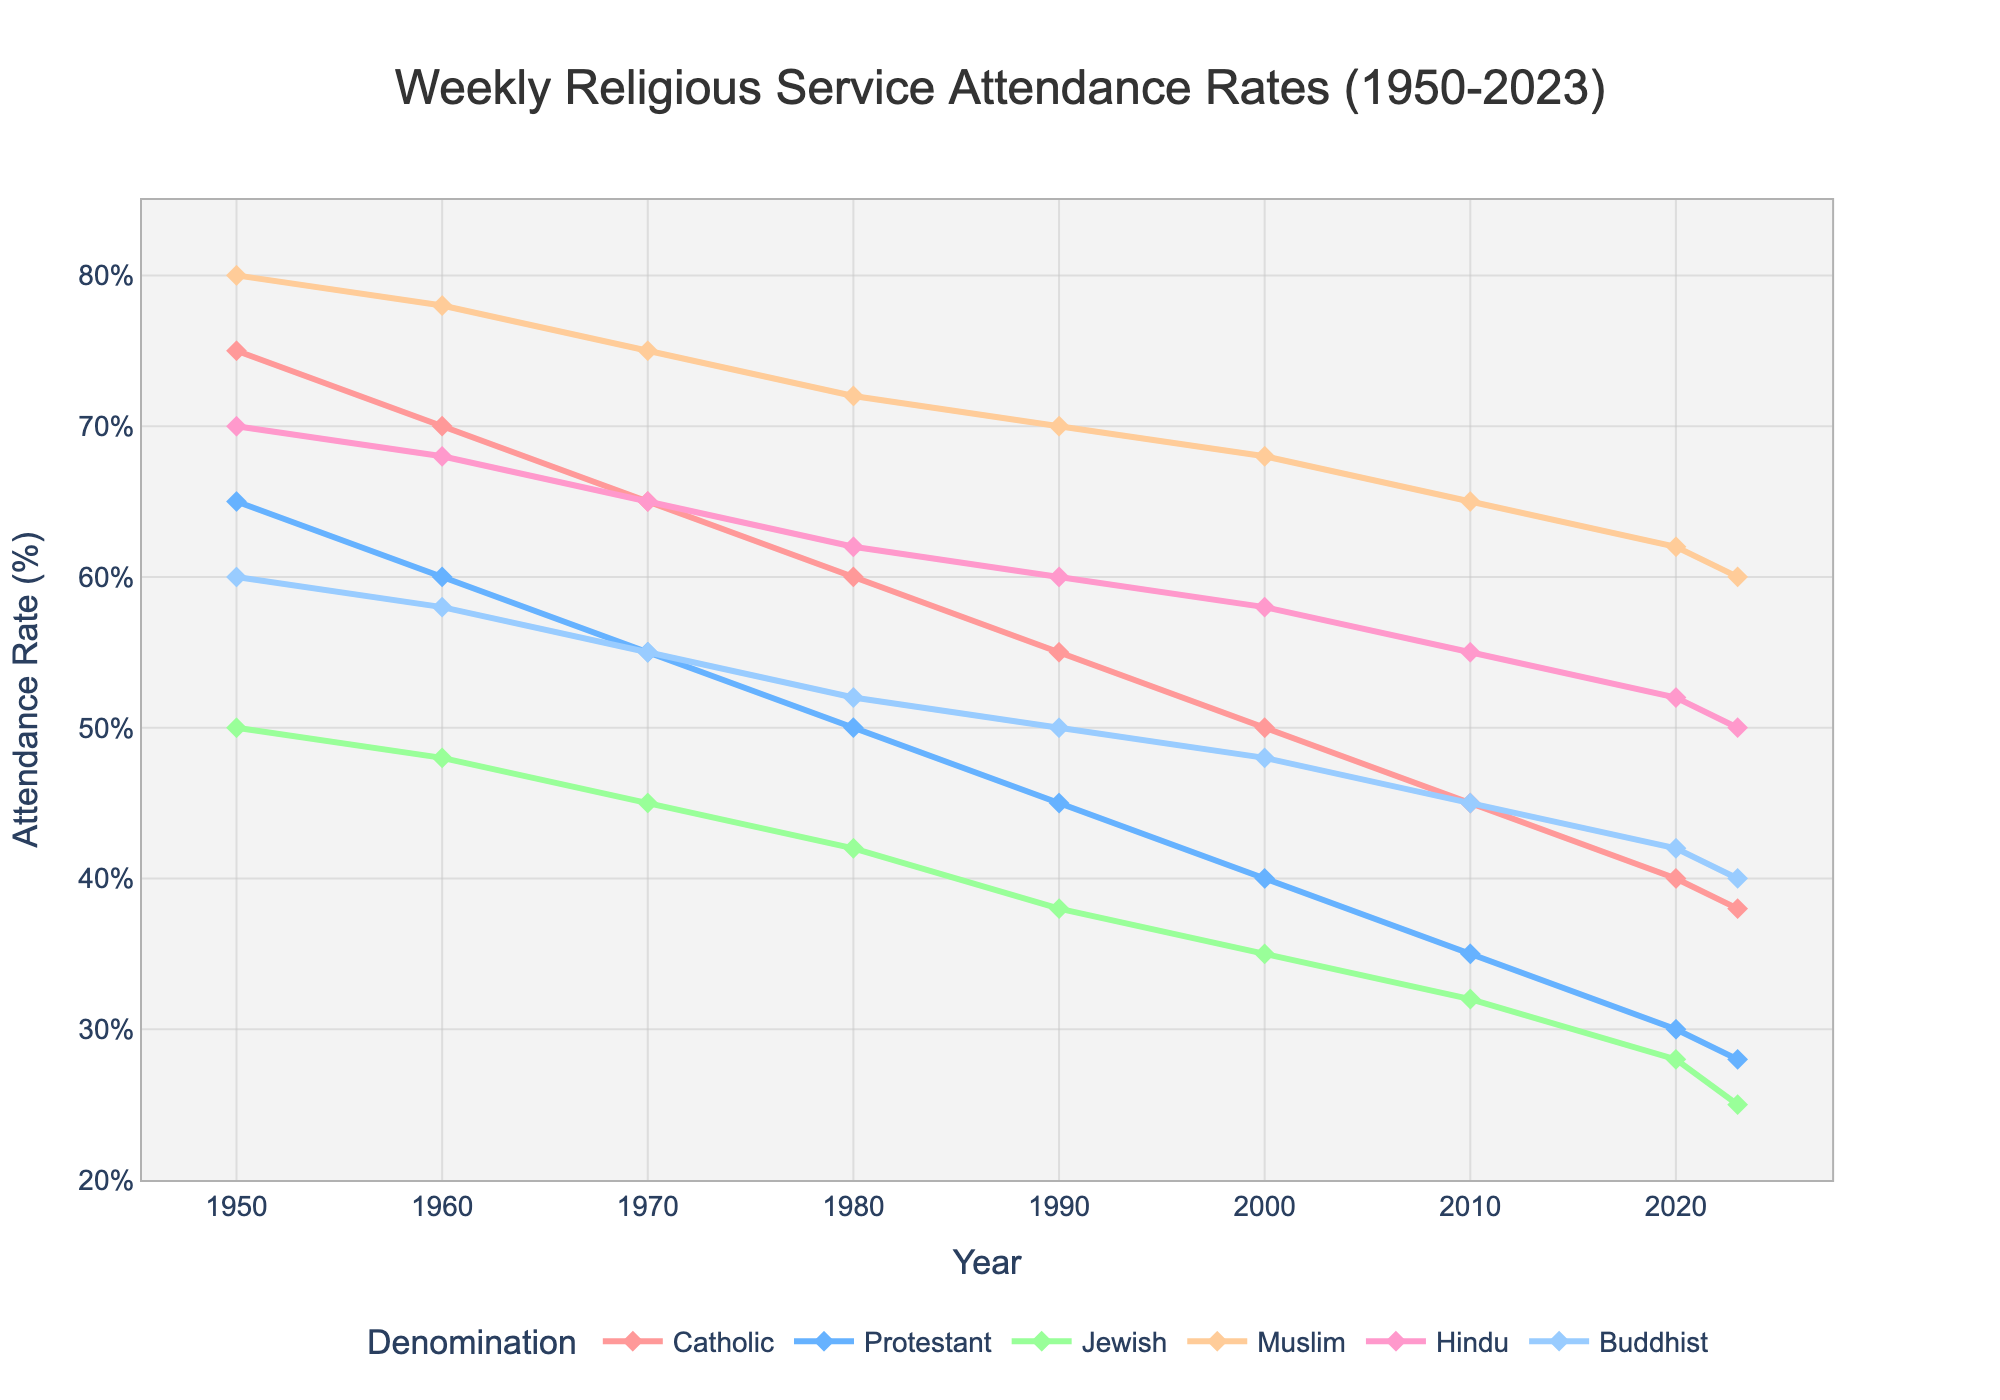What is the attendance rate for Catholics in 2000? Find the value on the y-axis corresponding to the Catholic line at the year 2000. The attendance rate for Catholics in 2000 is shown as 50%.
Answer: 50% Which denomination experienced the greatest decline in attendance rate from 1950 to 2023? Calculate the difference between the attendance rates in 1950 and 2023 for each denomination. Catholic (75-38=37), Protestant (65-28=37), Jewish (50-25=25), Muslim (80-60=20), Hindu (70-50=20), Buddhist (60-40=20). Both Catholics and Protestants experienced the greatest decline (37%).
Answer: Catholics and Protestants By how much did the attendance rate of Muslims decrease between 1980 and 2023? Subtract the attendance rate of Muslims in 2023 from the rate in 1980. The values are 72% (1980) and 60% (2023). 72 - 60 = 12
Answer: 12% Which denomination had the highest attendance rate in 1950, and what was the rate? Look at the highest point in the y-axis corresponding to 1950 among all the denominations. Muslims had the highest rate at 80% in 1950.
Answer: Muslims, 80% Compare the trends of Protestant and Jewish attendance rates from 1950 to 2023. Notice the declining trends of both denominations. Protestants declined from 65% to 28%, and Jews went from 50% to 25%. Both show a steady decline, with Protestants having a slightly steeper decrease.
Answer: Both declined, but Protestants steeper On average, how much did the attendance rate for Buddhists change per decade from 1950 to 2023? Calculate the total change from 1950 to 2023 for Buddhists (60-40=20). Divide this by the number of decades (2023-1950=73 years, approximately 7 decades). 20/7 ≈ 2.86
Answer: Approximately 2.86% per decade 